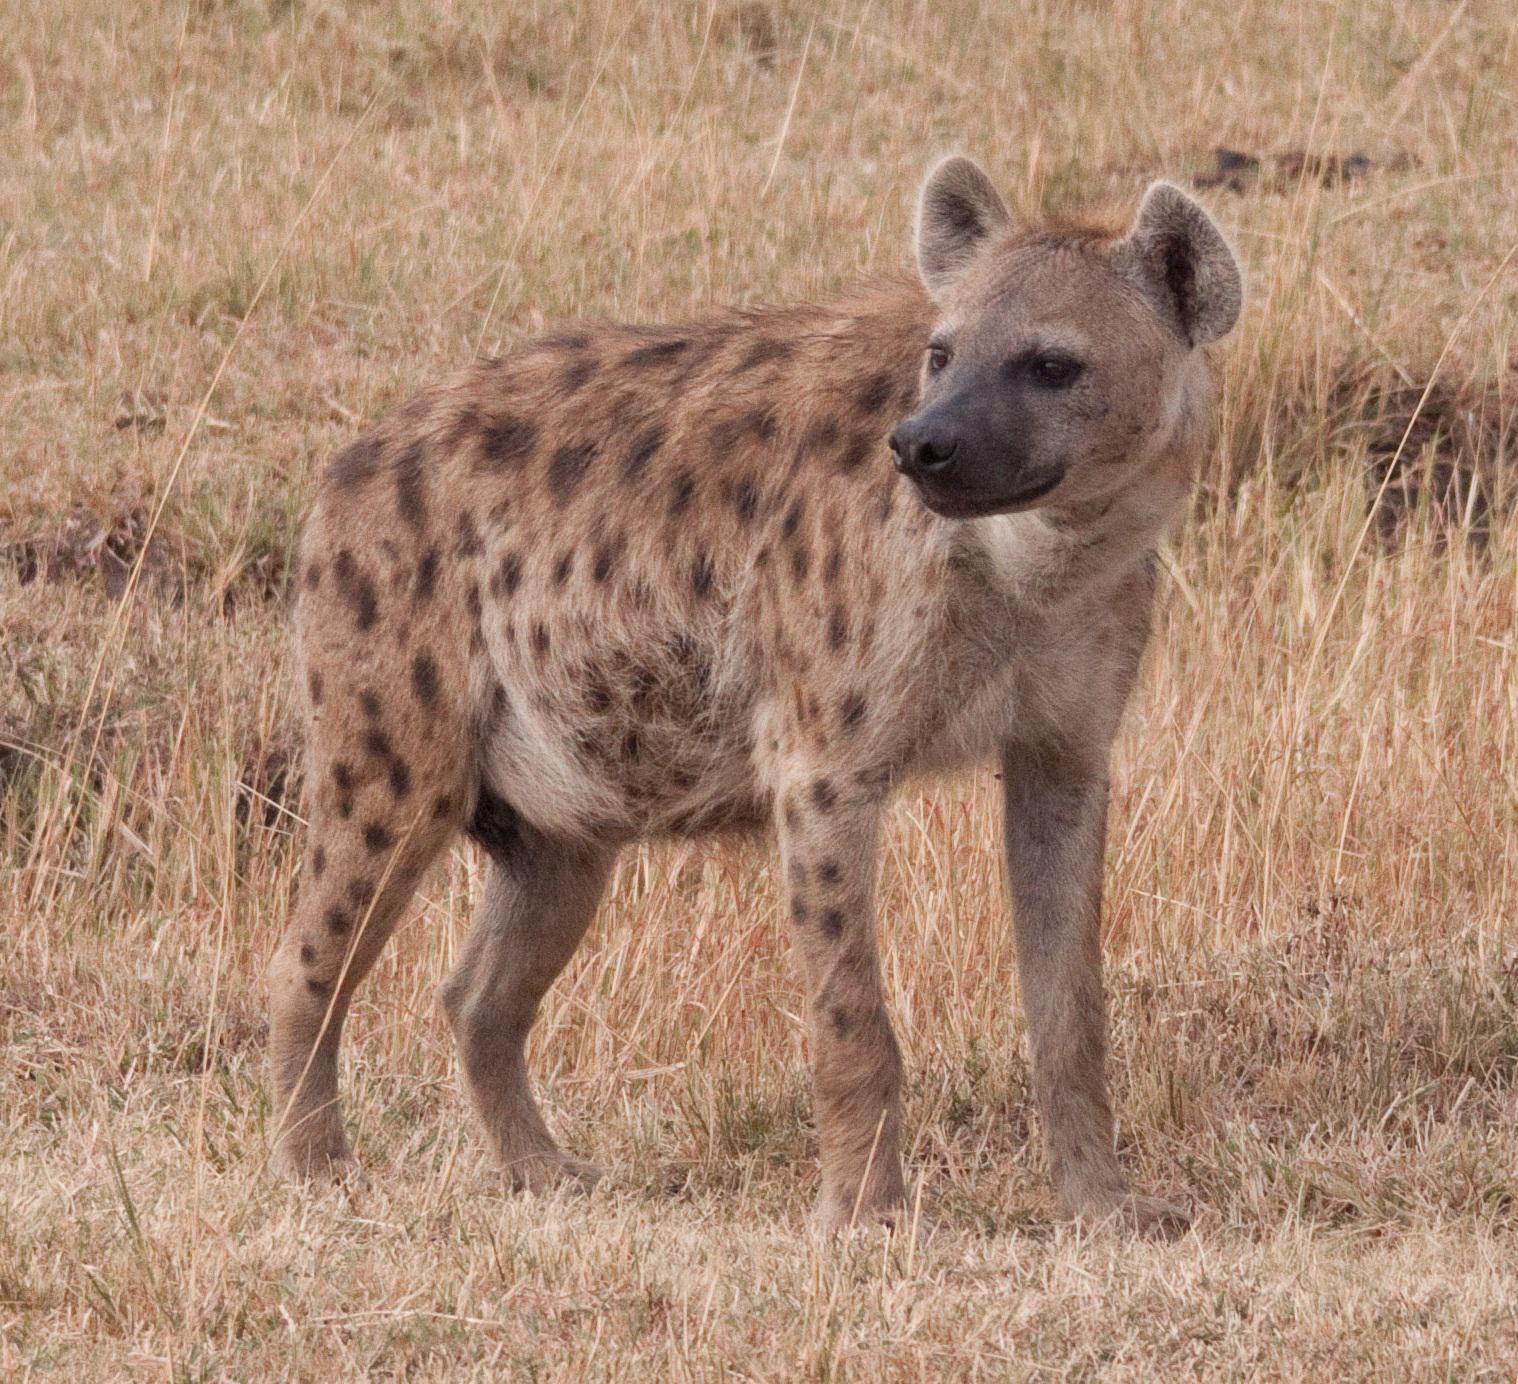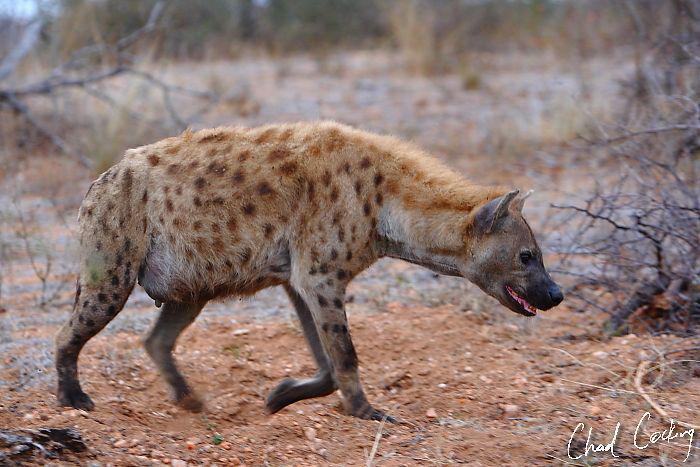The first image is the image on the left, the second image is the image on the right. For the images displayed, is the sentence "There are a total of 3 hyena's." factually correct? Answer yes or no. No. The first image is the image on the left, the second image is the image on the right. Analyze the images presented: Is the assertion "There are 2 animals facing opposite directions in the right image." valid? Answer yes or no. No. 